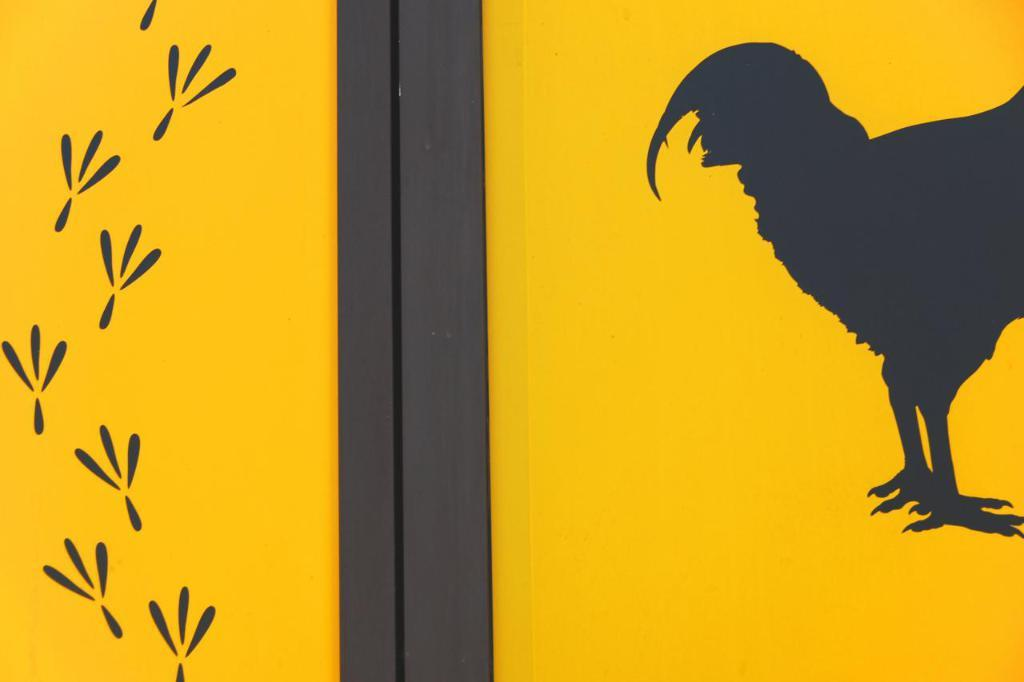What is present on the wall in the image? There is a painting of a hen on the wall. Are there any other markings or features on the wall? Yes, there are hen footsteps on the wall. Can you see a receipt for the painting of the hen on the wall in the image? There is no receipt present on the wall in the image. 